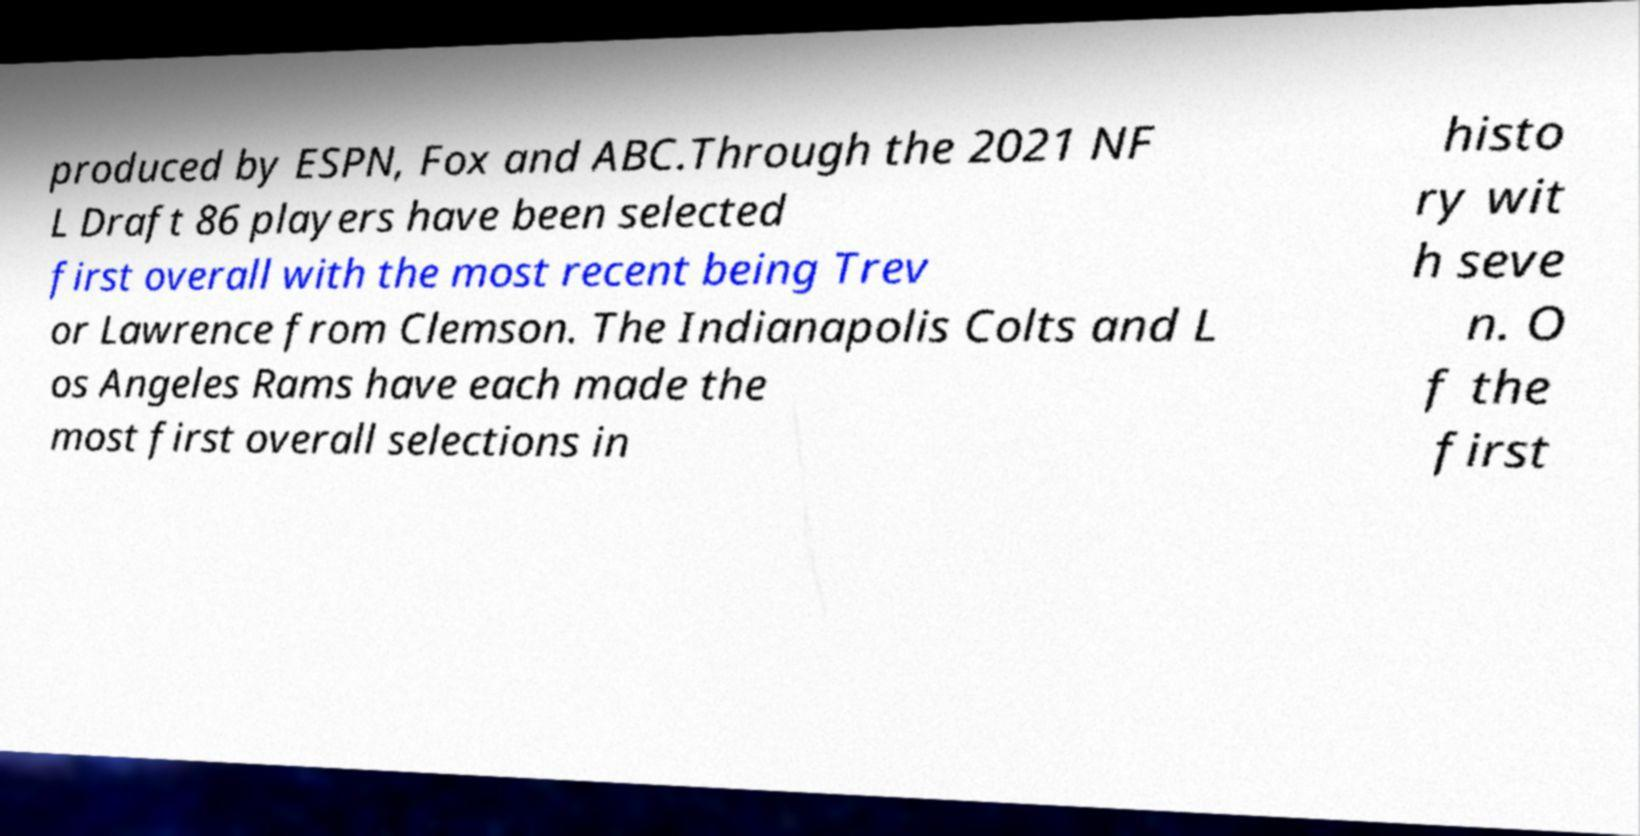Please identify and transcribe the text found in this image. produced by ESPN, Fox and ABC.Through the 2021 NF L Draft 86 players have been selected first overall with the most recent being Trev or Lawrence from Clemson. The Indianapolis Colts and L os Angeles Rams have each made the most first overall selections in histo ry wit h seve n. O f the first 